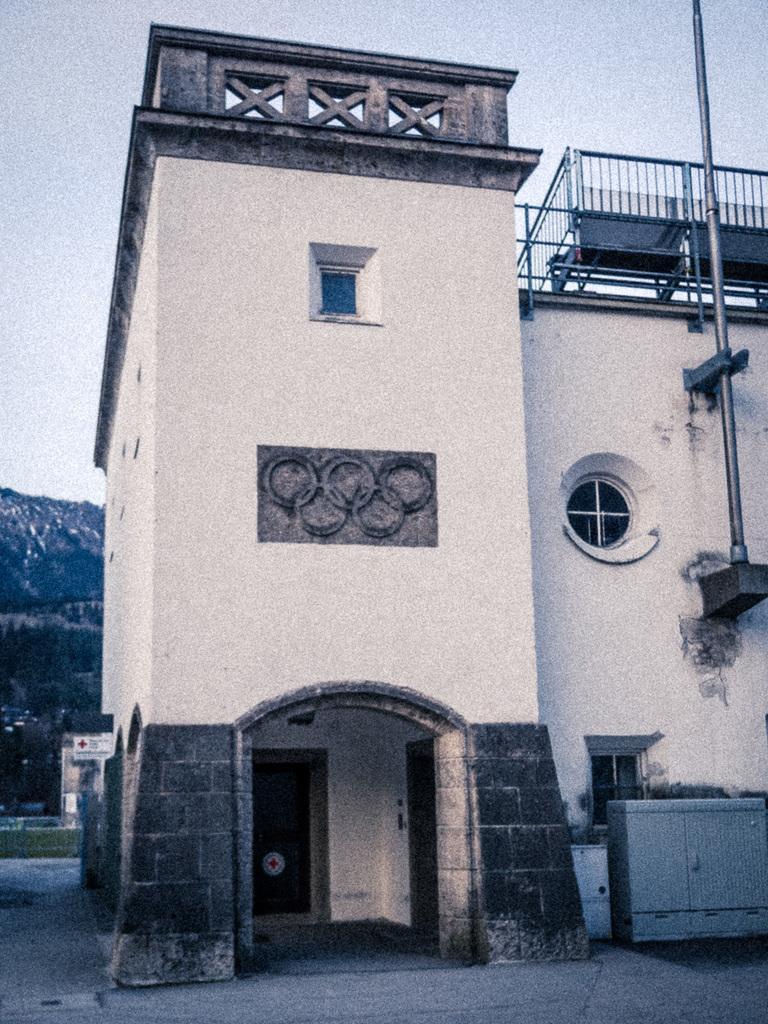Please provide a concise description of this image. This image consists of a building. At the bottom, there is a door. To the right, there is a pole. At the bottom, there is a road. To the left, there is a mountain. 